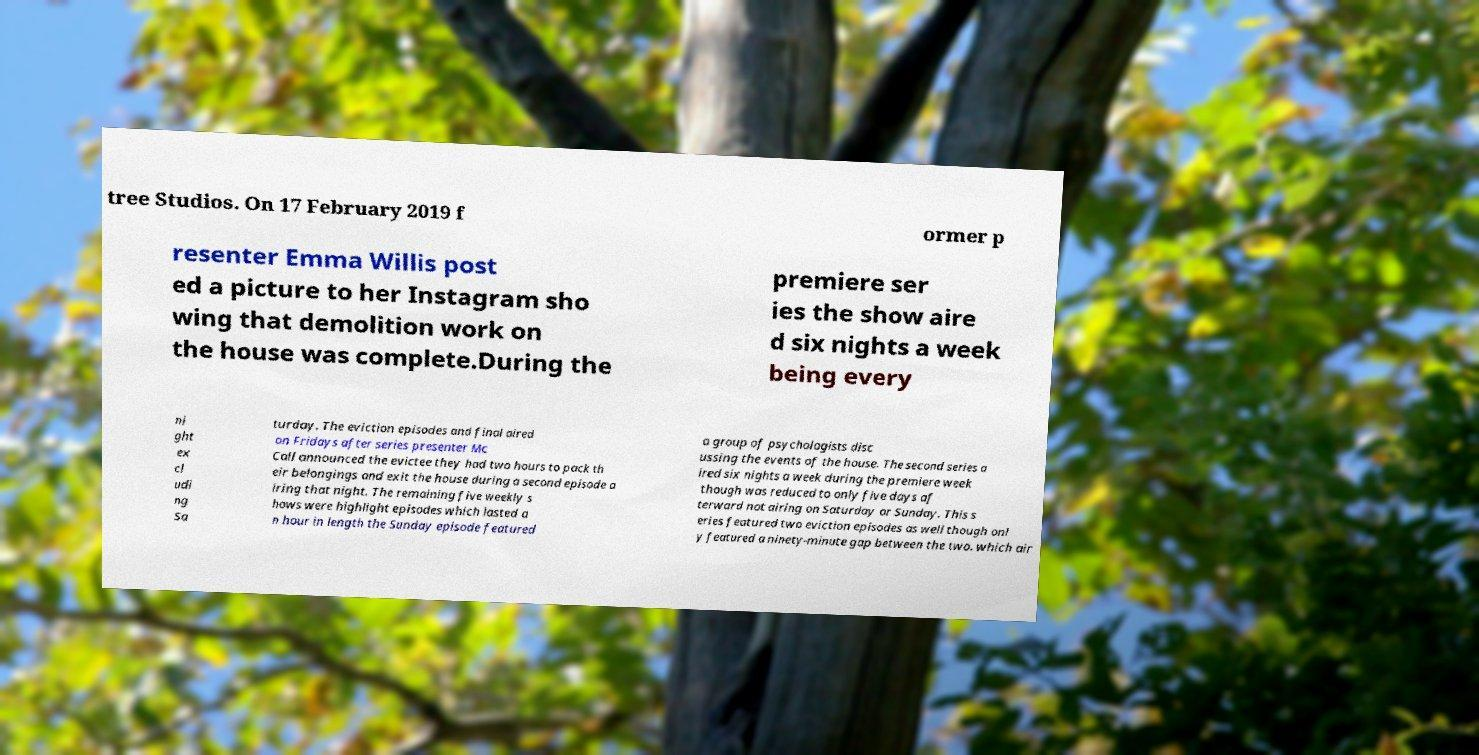What messages or text are displayed in this image? I need them in a readable, typed format. tree Studios. On 17 February 2019 f ormer p resenter Emma Willis post ed a picture to her Instagram sho wing that demolition work on the house was complete.During the premiere ser ies the show aire d six nights a week being every ni ght ex cl udi ng Sa turday. The eviction episodes and final aired on Fridays after series presenter Mc Call announced the evictee they had two hours to pack th eir belongings and exit the house during a second episode a iring that night. The remaining five weekly s hows were highlight episodes which lasted a n hour in length the Sunday episode featured a group of psychologists disc ussing the events of the house. The second series a ired six nights a week during the premiere week though was reduced to only five days af terward not airing on Saturday or Sunday. This s eries featured two eviction episodes as well though onl y featured a ninety-minute gap between the two. which air 